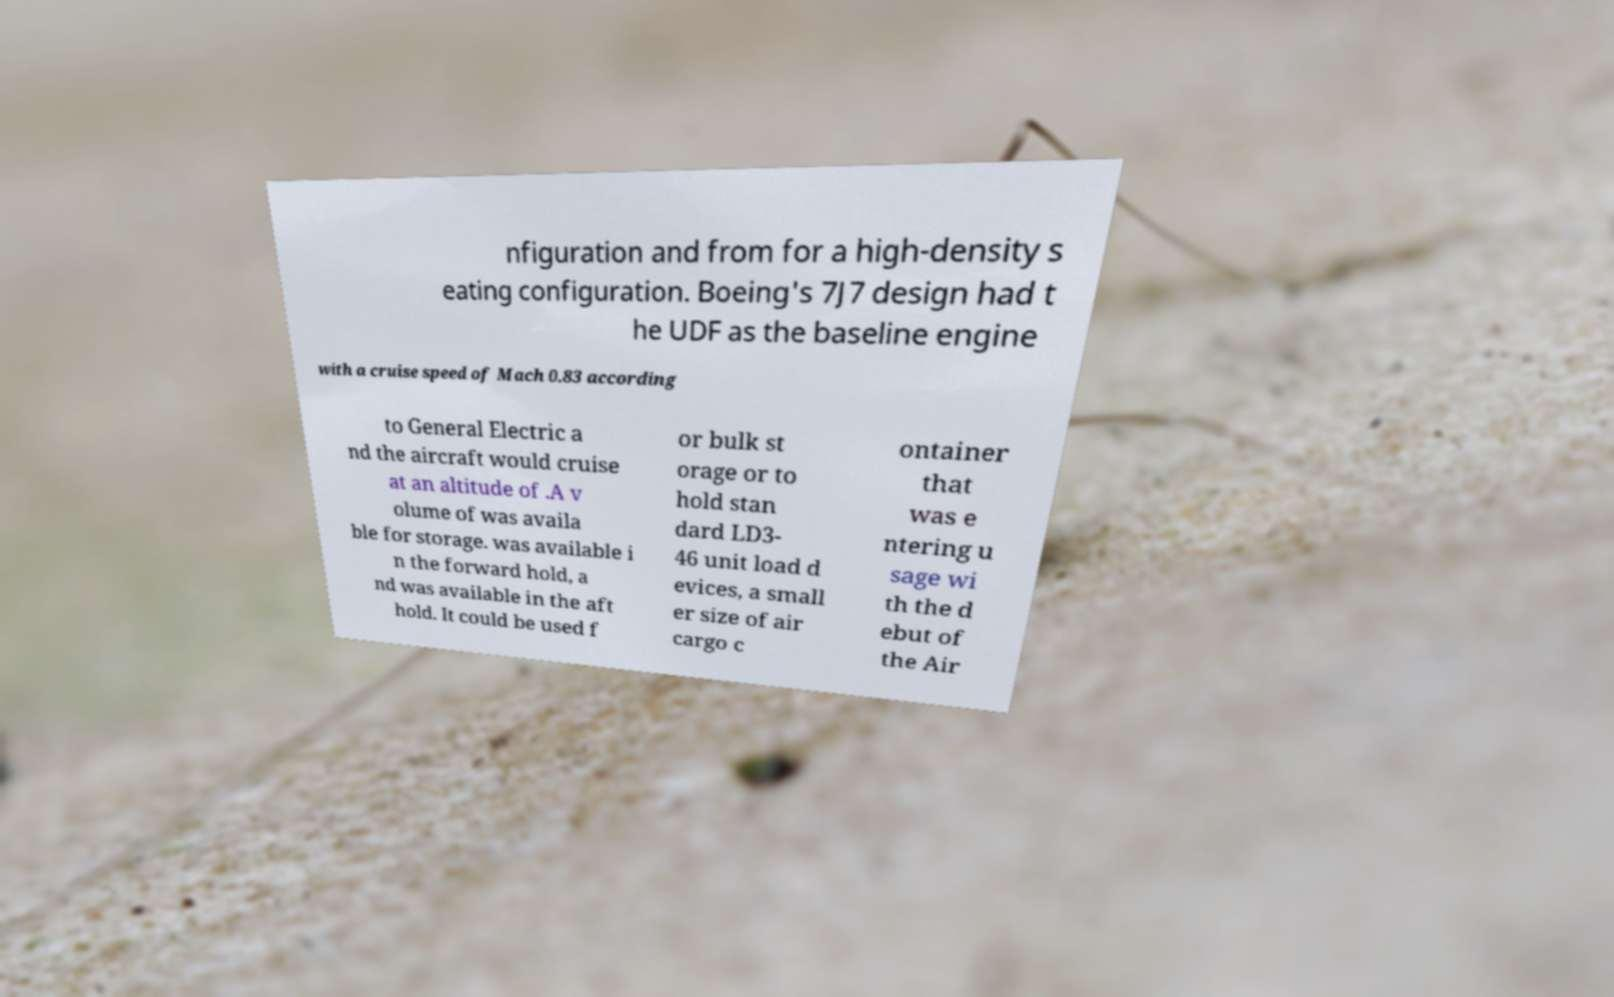Could you assist in decoding the text presented in this image and type it out clearly? nfiguration and from for a high-density s eating configuration. Boeing's 7J7 design had t he UDF as the baseline engine with a cruise speed of Mach 0.83 according to General Electric a nd the aircraft would cruise at an altitude of .A v olume of was availa ble for storage. was available i n the forward hold, a nd was available in the aft hold. It could be used f or bulk st orage or to hold stan dard LD3- 46 unit load d evices, a small er size of air cargo c ontainer that was e ntering u sage wi th the d ebut of the Air 